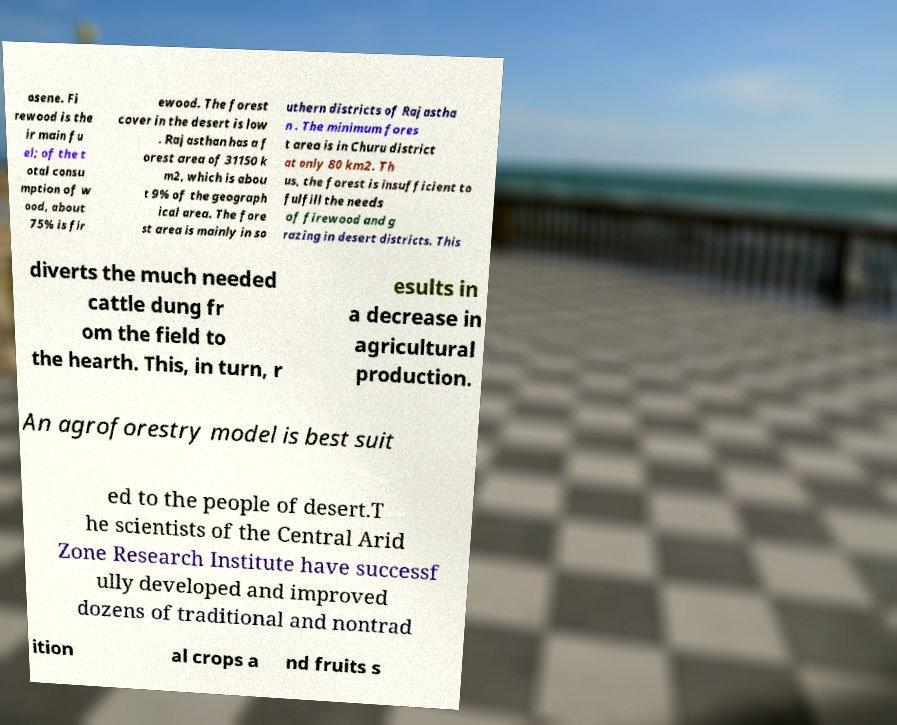Could you extract and type out the text from this image? osene. Fi rewood is the ir main fu el; of the t otal consu mption of w ood, about 75% is fir ewood. The forest cover in the desert is low . Rajasthan has a f orest area of 31150 k m2, which is abou t 9% of the geograph ical area. The fore st area is mainly in so uthern districts of Rajastha n . The minimum fores t area is in Churu district at only 80 km2. Th us, the forest is insufficient to fulfill the needs of firewood and g razing in desert districts. This diverts the much needed cattle dung fr om the field to the hearth. This, in turn, r esults in a decrease in agricultural production. An agroforestry model is best suit ed to the people of desert.T he scientists of the Central Arid Zone Research Institute have successf ully developed and improved dozens of traditional and nontrad ition al crops a nd fruits s 